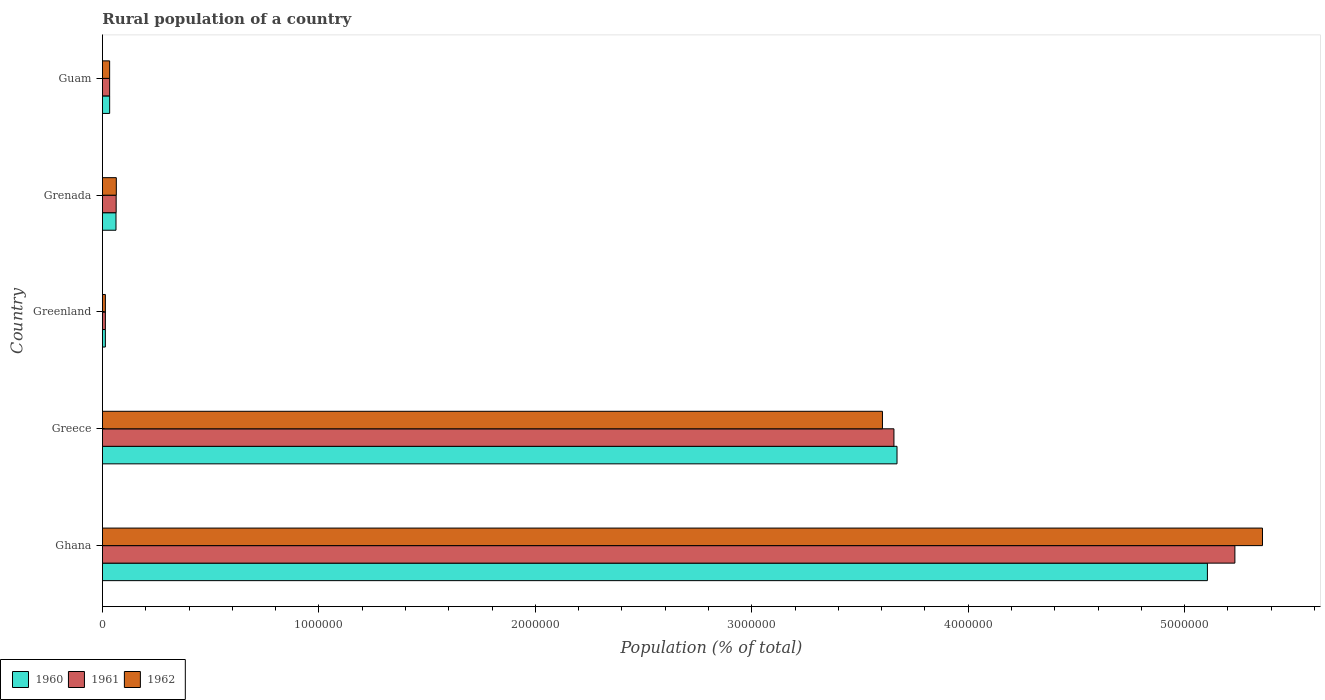How many different coloured bars are there?
Provide a short and direct response. 3. What is the label of the 2nd group of bars from the top?
Provide a succinct answer. Grenada. What is the rural population in 1962 in Grenada?
Provide a short and direct response. 6.40e+04. Across all countries, what is the maximum rural population in 1961?
Your answer should be very brief. 5.23e+06. Across all countries, what is the minimum rural population in 1960?
Provide a short and direct response. 1.35e+04. In which country was the rural population in 1962 maximum?
Keep it short and to the point. Ghana. In which country was the rural population in 1961 minimum?
Make the answer very short. Greenland. What is the total rural population in 1961 in the graph?
Keep it short and to the point. 9.00e+06. What is the difference between the rural population in 1961 in Ghana and that in Greece?
Offer a very short reply. 1.58e+06. What is the difference between the rural population in 1960 in Greenland and the rural population in 1962 in Grenada?
Offer a terse response. -5.06e+04. What is the average rural population in 1961 per country?
Provide a succinct answer. 1.80e+06. In how many countries, is the rural population in 1961 greater than 1200000 %?
Provide a succinct answer. 2. What is the ratio of the rural population in 1962 in Ghana to that in Greece?
Make the answer very short. 1.49. Is the rural population in 1961 in Greece less than that in Guam?
Ensure brevity in your answer.  No. What is the difference between the highest and the second highest rural population in 1961?
Your answer should be compact. 1.58e+06. What is the difference between the highest and the lowest rural population in 1960?
Ensure brevity in your answer.  5.09e+06. Is the sum of the rural population in 1962 in Ghana and Greece greater than the maximum rural population in 1961 across all countries?
Provide a short and direct response. Yes. What does the 1st bar from the bottom in Grenada represents?
Provide a succinct answer. 1960. How many bars are there?
Ensure brevity in your answer.  15. Are the values on the major ticks of X-axis written in scientific E-notation?
Your answer should be very brief. No. Where does the legend appear in the graph?
Offer a terse response. Bottom left. What is the title of the graph?
Your answer should be very brief. Rural population of a country. Does "1967" appear as one of the legend labels in the graph?
Your response must be concise. No. What is the label or title of the X-axis?
Your answer should be compact. Population (% of total). What is the Population (% of total) in 1960 in Ghana?
Your answer should be very brief. 5.11e+06. What is the Population (% of total) of 1961 in Ghana?
Provide a short and direct response. 5.23e+06. What is the Population (% of total) of 1962 in Ghana?
Keep it short and to the point. 5.36e+06. What is the Population (% of total) of 1960 in Greece?
Your answer should be compact. 3.67e+06. What is the Population (% of total) of 1961 in Greece?
Your answer should be compact. 3.66e+06. What is the Population (% of total) of 1962 in Greece?
Ensure brevity in your answer.  3.60e+06. What is the Population (% of total) of 1960 in Greenland?
Your response must be concise. 1.35e+04. What is the Population (% of total) in 1961 in Greenland?
Your answer should be compact. 1.35e+04. What is the Population (% of total) in 1962 in Greenland?
Provide a short and direct response. 1.35e+04. What is the Population (% of total) of 1960 in Grenada?
Ensure brevity in your answer.  6.26e+04. What is the Population (% of total) of 1961 in Grenada?
Keep it short and to the point. 6.34e+04. What is the Population (% of total) in 1962 in Grenada?
Your answer should be compact. 6.40e+04. What is the Population (% of total) in 1960 in Guam?
Offer a very short reply. 3.33e+04. What is the Population (% of total) of 1961 in Guam?
Offer a terse response. 3.32e+04. What is the Population (% of total) in 1962 in Guam?
Provide a succinct answer. 3.32e+04. Across all countries, what is the maximum Population (% of total) of 1960?
Your response must be concise. 5.11e+06. Across all countries, what is the maximum Population (% of total) of 1961?
Provide a short and direct response. 5.23e+06. Across all countries, what is the maximum Population (% of total) of 1962?
Make the answer very short. 5.36e+06. Across all countries, what is the minimum Population (% of total) of 1960?
Offer a terse response. 1.35e+04. Across all countries, what is the minimum Population (% of total) of 1961?
Ensure brevity in your answer.  1.35e+04. Across all countries, what is the minimum Population (% of total) of 1962?
Offer a very short reply. 1.35e+04. What is the total Population (% of total) of 1960 in the graph?
Your response must be concise. 8.89e+06. What is the total Population (% of total) of 1961 in the graph?
Offer a terse response. 9.00e+06. What is the total Population (% of total) in 1962 in the graph?
Offer a terse response. 9.07e+06. What is the difference between the Population (% of total) of 1960 in Ghana and that in Greece?
Keep it short and to the point. 1.43e+06. What is the difference between the Population (% of total) of 1961 in Ghana and that in Greece?
Ensure brevity in your answer.  1.58e+06. What is the difference between the Population (% of total) of 1962 in Ghana and that in Greece?
Your answer should be very brief. 1.76e+06. What is the difference between the Population (% of total) of 1960 in Ghana and that in Greenland?
Offer a terse response. 5.09e+06. What is the difference between the Population (% of total) of 1961 in Ghana and that in Greenland?
Ensure brevity in your answer.  5.22e+06. What is the difference between the Population (% of total) of 1962 in Ghana and that in Greenland?
Your answer should be very brief. 5.35e+06. What is the difference between the Population (% of total) of 1960 in Ghana and that in Grenada?
Provide a short and direct response. 5.04e+06. What is the difference between the Population (% of total) of 1961 in Ghana and that in Grenada?
Give a very brief answer. 5.17e+06. What is the difference between the Population (% of total) in 1962 in Ghana and that in Grenada?
Offer a very short reply. 5.30e+06. What is the difference between the Population (% of total) of 1960 in Ghana and that in Guam?
Make the answer very short. 5.07e+06. What is the difference between the Population (% of total) of 1961 in Ghana and that in Guam?
Keep it short and to the point. 5.20e+06. What is the difference between the Population (% of total) of 1962 in Ghana and that in Guam?
Offer a terse response. 5.33e+06. What is the difference between the Population (% of total) of 1960 in Greece and that in Greenland?
Offer a terse response. 3.66e+06. What is the difference between the Population (% of total) in 1961 in Greece and that in Greenland?
Offer a very short reply. 3.64e+06. What is the difference between the Population (% of total) of 1962 in Greece and that in Greenland?
Provide a succinct answer. 3.59e+06. What is the difference between the Population (% of total) of 1960 in Greece and that in Grenada?
Give a very brief answer. 3.61e+06. What is the difference between the Population (% of total) in 1961 in Greece and that in Grenada?
Make the answer very short. 3.59e+06. What is the difference between the Population (% of total) of 1962 in Greece and that in Grenada?
Provide a succinct answer. 3.54e+06. What is the difference between the Population (% of total) of 1960 in Greece and that in Guam?
Your response must be concise. 3.64e+06. What is the difference between the Population (% of total) of 1961 in Greece and that in Guam?
Give a very brief answer. 3.62e+06. What is the difference between the Population (% of total) of 1962 in Greece and that in Guam?
Provide a short and direct response. 3.57e+06. What is the difference between the Population (% of total) of 1960 in Greenland and that in Grenada?
Provide a short and direct response. -4.91e+04. What is the difference between the Population (% of total) of 1961 in Greenland and that in Grenada?
Your answer should be very brief. -4.99e+04. What is the difference between the Population (% of total) in 1962 in Greenland and that in Grenada?
Your answer should be compact. -5.05e+04. What is the difference between the Population (% of total) in 1960 in Greenland and that in Guam?
Keep it short and to the point. -1.98e+04. What is the difference between the Population (% of total) in 1961 in Greenland and that in Guam?
Give a very brief answer. -1.97e+04. What is the difference between the Population (% of total) of 1962 in Greenland and that in Guam?
Your answer should be very brief. -1.97e+04. What is the difference between the Population (% of total) in 1960 in Grenada and that in Guam?
Provide a short and direct response. 2.93e+04. What is the difference between the Population (% of total) in 1961 in Grenada and that in Guam?
Offer a terse response. 3.02e+04. What is the difference between the Population (% of total) of 1962 in Grenada and that in Guam?
Ensure brevity in your answer.  3.08e+04. What is the difference between the Population (% of total) of 1960 in Ghana and the Population (% of total) of 1961 in Greece?
Your answer should be compact. 1.45e+06. What is the difference between the Population (% of total) of 1960 in Ghana and the Population (% of total) of 1962 in Greece?
Provide a succinct answer. 1.50e+06. What is the difference between the Population (% of total) in 1961 in Ghana and the Population (% of total) in 1962 in Greece?
Give a very brief answer. 1.63e+06. What is the difference between the Population (% of total) in 1960 in Ghana and the Population (% of total) in 1961 in Greenland?
Provide a succinct answer. 5.09e+06. What is the difference between the Population (% of total) in 1960 in Ghana and the Population (% of total) in 1962 in Greenland?
Make the answer very short. 5.09e+06. What is the difference between the Population (% of total) of 1961 in Ghana and the Population (% of total) of 1962 in Greenland?
Make the answer very short. 5.22e+06. What is the difference between the Population (% of total) in 1960 in Ghana and the Population (% of total) in 1961 in Grenada?
Keep it short and to the point. 5.04e+06. What is the difference between the Population (% of total) of 1960 in Ghana and the Population (% of total) of 1962 in Grenada?
Your response must be concise. 5.04e+06. What is the difference between the Population (% of total) of 1961 in Ghana and the Population (% of total) of 1962 in Grenada?
Your response must be concise. 5.17e+06. What is the difference between the Population (% of total) in 1960 in Ghana and the Population (% of total) in 1961 in Guam?
Your response must be concise. 5.07e+06. What is the difference between the Population (% of total) of 1960 in Ghana and the Population (% of total) of 1962 in Guam?
Provide a short and direct response. 5.07e+06. What is the difference between the Population (% of total) in 1961 in Ghana and the Population (% of total) in 1962 in Guam?
Your response must be concise. 5.20e+06. What is the difference between the Population (% of total) in 1960 in Greece and the Population (% of total) in 1961 in Greenland?
Offer a very short reply. 3.66e+06. What is the difference between the Population (% of total) in 1960 in Greece and the Population (% of total) in 1962 in Greenland?
Provide a succinct answer. 3.66e+06. What is the difference between the Population (% of total) in 1961 in Greece and the Population (% of total) in 1962 in Greenland?
Ensure brevity in your answer.  3.64e+06. What is the difference between the Population (% of total) of 1960 in Greece and the Population (% of total) of 1961 in Grenada?
Make the answer very short. 3.61e+06. What is the difference between the Population (% of total) in 1960 in Greece and the Population (% of total) in 1962 in Grenada?
Keep it short and to the point. 3.61e+06. What is the difference between the Population (% of total) in 1961 in Greece and the Population (% of total) in 1962 in Grenada?
Offer a very short reply. 3.59e+06. What is the difference between the Population (% of total) of 1960 in Greece and the Population (% of total) of 1961 in Guam?
Give a very brief answer. 3.64e+06. What is the difference between the Population (% of total) of 1960 in Greece and the Population (% of total) of 1962 in Guam?
Ensure brevity in your answer.  3.64e+06. What is the difference between the Population (% of total) of 1961 in Greece and the Population (% of total) of 1962 in Guam?
Make the answer very short. 3.62e+06. What is the difference between the Population (% of total) of 1960 in Greenland and the Population (% of total) of 1961 in Grenada?
Offer a very short reply. -4.99e+04. What is the difference between the Population (% of total) in 1960 in Greenland and the Population (% of total) in 1962 in Grenada?
Provide a succinct answer. -5.06e+04. What is the difference between the Population (% of total) in 1961 in Greenland and the Population (% of total) in 1962 in Grenada?
Ensure brevity in your answer.  -5.05e+04. What is the difference between the Population (% of total) of 1960 in Greenland and the Population (% of total) of 1961 in Guam?
Provide a succinct answer. -1.97e+04. What is the difference between the Population (% of total) of 1960 in Greenland and the Population (% of total) of 1962 in Guam?
Offer a very short reply. -1.97e+04. What is the difference between the Population (% of total) in 1961 in Greenland and the Population (% of total) in 1962 in Guam?
Keep it short and to the point. -1.96e+04. What is the difference between the Population (% of total) of 1960 in Grenada and the Population (% of total) of 1961 in Guam?
Give a very brief answer. 2.94e+04. What is the difference between the Population (% of total) in 1960 in Grenada and the Population (% of total) in 1962 in Guam?
Ensure brevity in your answer.  2.94e+04. What is the difference between the Population (% of total) in 1961 in Grenada and the Population (% of total) in 1962 in Guam?
Offer a terse response. 3.02e+04. What is the average Population (% of total) in 1960 per country?
Offer a terse response. 1.78e+06. What is the average Population (% of total) in 1961 per country?
Offer a very short reply. 1.80e+06. What is the average Population (% of total) of 1962 per country?
Offer a terse response. 1.81e+06. What is the difference between the Population (% of total) of 1960 and Population (% of total) of 1961 in Ghana?
Your answer should be compact. -1.27e+05. What is the difference between the Population (% of total) in 1960 and Population (% of total) in 1962 in Ghana?
Offer a very short reply. -2.55e+05. What is the difference between the Population (% of total) in 1961 and Population (% of total) in 1962 in Ghana?
Your answer should be very brief. -1.27e+05. What is the difference between the Population (% of total) of 1960 and Population (% of total) of 1961 in Greece?
Your response must be concise. 1.42e+04. What is the difference between the Population (% of total) of 1960 and Population (% of total) of 1962 in Greece?
Your answer should be compact. 6.73e+04. What is the difference between the Population (% of total) in 1961 and Population (% of total) in 1962 in Greece?
Your answer should be compact. 5.31e+04. What is the difference between the Population (% of total) in 1960 and Population (% of total) in 1961 in Greenland?
Keep it short and to the point. -69. What is the difference between the Population (% of total) of 1960 and Population (% of total) of 1962 in Greenland?
Your response must be concise. -32. What is the difference between the Population (% of total) in 1960 and Population (% of total) in 1961 in Grenada?
Ensure brevity in your answer.  -804. What is the difference between the Population (% of total) of 1960 and Population (% of total) of 1962 in Grenada?
Provide a short and direct response. -1439. What is the difference between the Population (% of total) of 1961 and Population (% of total) of 1962 in Grenada?
Provide a succinct answer. -635. What is the difference between the Population (% of total) of 1960 and Population (% of total) of 1961 in Guam?
Make the answer very short. 73. What is the difference between the Population (% of total) in 1960 and Population (% of total) in 1962 in Guam?
Offer a terse response. 79. What is the difference between the Population (% of total) in 1961 and Population (% of total) in 1962 in Guam?
Your answer should be very brief. 6. What is the ratio of the Population (% of total) in 1960 in Ghana to that in Greece?
Your response must be concise. 1.39. What is the ratio of the Population (% of total) in 1961 in Ghana to that in Greece?
Your answer should be very brief. 1.43. What is the ratio of the Population (% of total) in 1962 in Ghana to that in Greece?
Provide a succinct answer. 1.49. What is the ratio of the Population (% of total) of 1960 in Ghana to that in Greenland?
Your answer should be compact. 378.86. What is the ratio of the Population (% of total) of 1961 in Ghana to that in Greenland?
Your answer should be compact. 386.31. What is the ratio of the Population (% of total) in 1962 in Ghana to that in Greenland?
Keep it short and to the point. 396.8. What is the ratio of the Population (% of total) in 1960 in Ghana to that in Grenada?
Keep it short and to the point. 81.55. What is the ratio of the Population (% of total) in 1961 in Ghana to that in Grenada?
Ensure brevity in your answer.  82.52. What is the ratio of the Population (% of total) of 1962 in Ghana to that in Grenada?
Offer a terse response. 83.69. What is the ratio of the Population (% of total) of 1960 in Ghana to that in Guam?
Provide a short and direct response. 153.45. What is the ratio of the Population (% of total) in 1961 in Ghana to that in Guam?
Make the answer very short. 157.61. What is the ratio of the Population (% of total) in 1962 in Ghana to that in Guam?
Give a very brief answer. 161.48. What is the ratio of the Population (% of total) in 1960 in Greece to that in Greenland?
Your answer should be compact. 272.43. What is the ratio of the Population (% of total) of 1961 in Greece to that in Greenland?
Provide a short and direct response. 270. What is the ratio of the Population (% of total) in 1962 in Greece to that in Greenland?
Your answer should be very brief. 266.81. What is the ratio of the Population (% of total) of 1960 in Greece to that in Grenada?
Keep it short and to the point. 58.64. What is the ratio of the Population (% of total) of 1961 in Greece to that in Grenada?
Your answer should be compact. 57.68. What is the ratio of the Population (% of total) in 1962 in Greece to that in Grenada?
Offer a very short reply. 56.27. What is the ratio of the Population (% of total) of 1960 in Greece to that in Guam?
Provide a succinct answer. 110.34. What is the ratio of the Population (% of total) in 1961 in Greece to that in Guam?
Provide a succinct answer. 110.16. What is the ratio of the Population (% of total) in 1962 in Greece to that in Guam?
Make the answer very short. 108.58. What is the ratio of the Population (% of total) of 1960 in Greenland to that in Grenada?
Your answer should be compact. 0.22. What is the ratio of the Population (% of total) in 1961 in Greenland to that in Grenada?
Ensure brevity in your answer.  0.21. What is the ratio of the Population (% of total) in 1962 in Greenland to that in Grenada?
Make the answer very short. 0.21. What is the ratio of the Population (% of total) of 1960 in Greenland to that in Guam?
Offer a terse response. 0.41. What is the ratio of the Population (% of total) of 1961 in Greenland to that in Guam?
Your response must be concise. 0.41. What is the ratio of the Population (% of total) in 1962 in Greenland to that in Guam?
Make the answer very short. 0.41. What is the ratio of the Population (% of total) of 1960 in Grenada to that in Guam?
Provide a short and direct response. 1.88. What is the ratio of the Population (% of total) of 1961 in Grenada to that in Guam?
Give a very brief answer. 1.91. What is the ratio of the Population (% of total) in 1962 in Grenada to that in Guam?
Offer a terse response. 1.93. What is the difference between the highest and the second highest Population (% of total) of 1960?
Ensure brevity in your answer.  1.43e+06. What is the difference between the highest and the second highest Population (% of total) of 1961?
Offer a terse response. 1.58e+06. What is the difference between the highest and the second highest Population (% of total) of 1962?
Ensure brevity in your answer.  1.76e+06. What is the difference between the highest and the lowest Population (% of total) of 1960?
Ensure brevity in your answer.  5.09e+06. What is the difference between the highest and the lowest Population (% of total) in 1961?
Give a very brief answer. 5.22e+06. What is the difference between the highest and the lowest Population (% of total) in 1962?
Ensure brevity in your answer.  5.35e+06. 